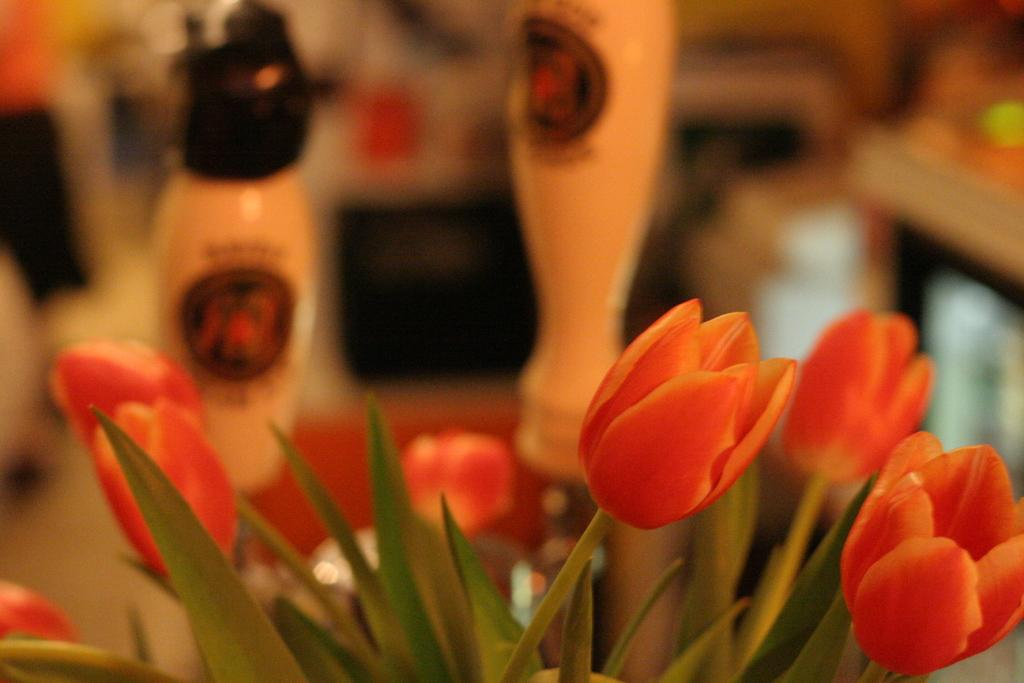What is the main object in the image? There is a flower vase in the image. What is inside the vase? The vase contains flowers. What else can be seen in the background of the image? There are two bottles in the background of the image. How would you describe the background of the image? The background is blurred. What song is being played in the background of the image? There is no information about a song being played in the image. The background is blurred, but it does not indicate any audio source. 